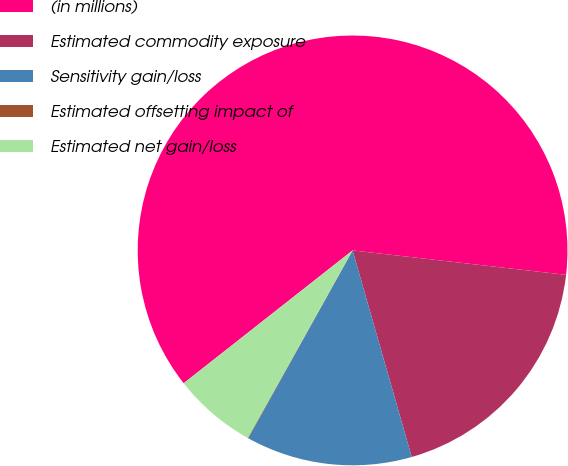Convert chart. <chart><loc_0><loc_0><loc_500><loc_500><pie_chart><fcel>(in millions)<fcel>Estimated commodity exposure<fcel>Sensitivity gain/loss<fcel>Estimated offsetting impact of<fcel>Estimated net gain/loss<nl><fcel>62.42%<fcel>18.75%<fcel>12.51%<fcel>0.04%<fcel>6.28%<nl></chart> 